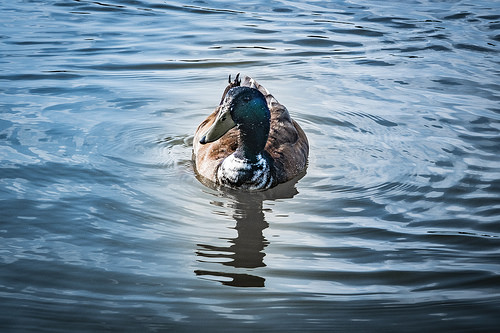<image>
Can you confirm if the duck is next to the water? No. The duck is not positioned next to the water. They are located in different areas of the scene. Is there a duck in the water? Yes. The duck is contained within or inside the water, showing a containment relationship. Where is the duck in relation to the river? Is it above the river? No. The duck is not positioned above the river. The vertical arrangement shows a different relationship. 